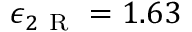Convert formula to latex. <formula><loc_0><loc_0><loc_500><loc_500>\epsilon _ { 2 R } = 1 . 6 3</formula> 